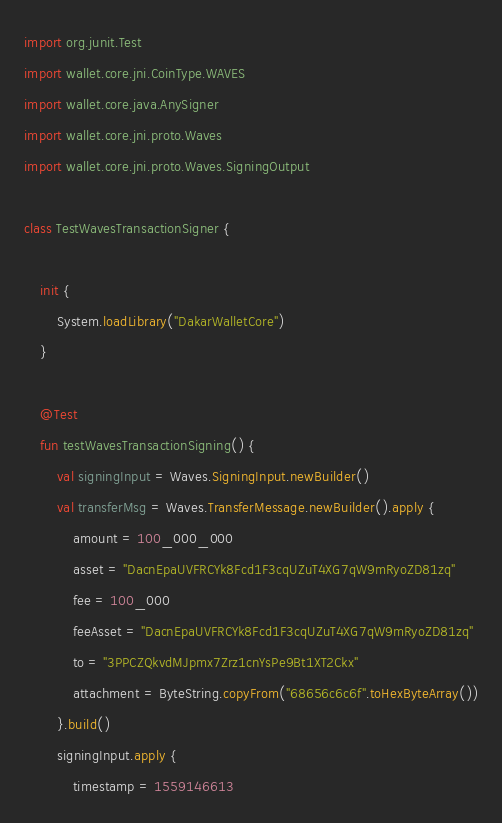Convert code to text. <code><loc_0><loc_0><loc_500><loc_500><_Kotlin_>import org.junit.Test
import wallet.core.jni.CoinType.WAVES
import wallet.core.java.AnySigner
import wallet.core.jni.proto.Waves
import wallet.core.jni.proto.Waves.SigningOutput

class TestWavesTransactionSigner {

    init {
        System.loadLibrary("DakarWalletCore")
    }

    @Test
    fun testWavesTransactionSigning() {
        val signingInput = Waves.SigningInput.newBuilder()
        val transferMsg = Waves.TransferMessage.newBuilder().apply {
            amount = 100_000_000
            asset = "DacnEpaUVFRCYk8Fcd1F3cqUZuT4XG7qW9mRyoZD81zq"
            fee = 100_000
            feeAsset = "DacnEpaUVFRCYk8Fcd1F3cqUZuT4XG7qW9mRyoZD81zq"
            to = "3PPCZQkvdMJpmx7Zrz1cnYsPe9Bt1XT2Ckx"
            attachment = ByteString.copyFrom("68656c6c6f".toHexByteArray())
        }.build()
        signingInput.apply {
            timestamp = 1559146613</code> 